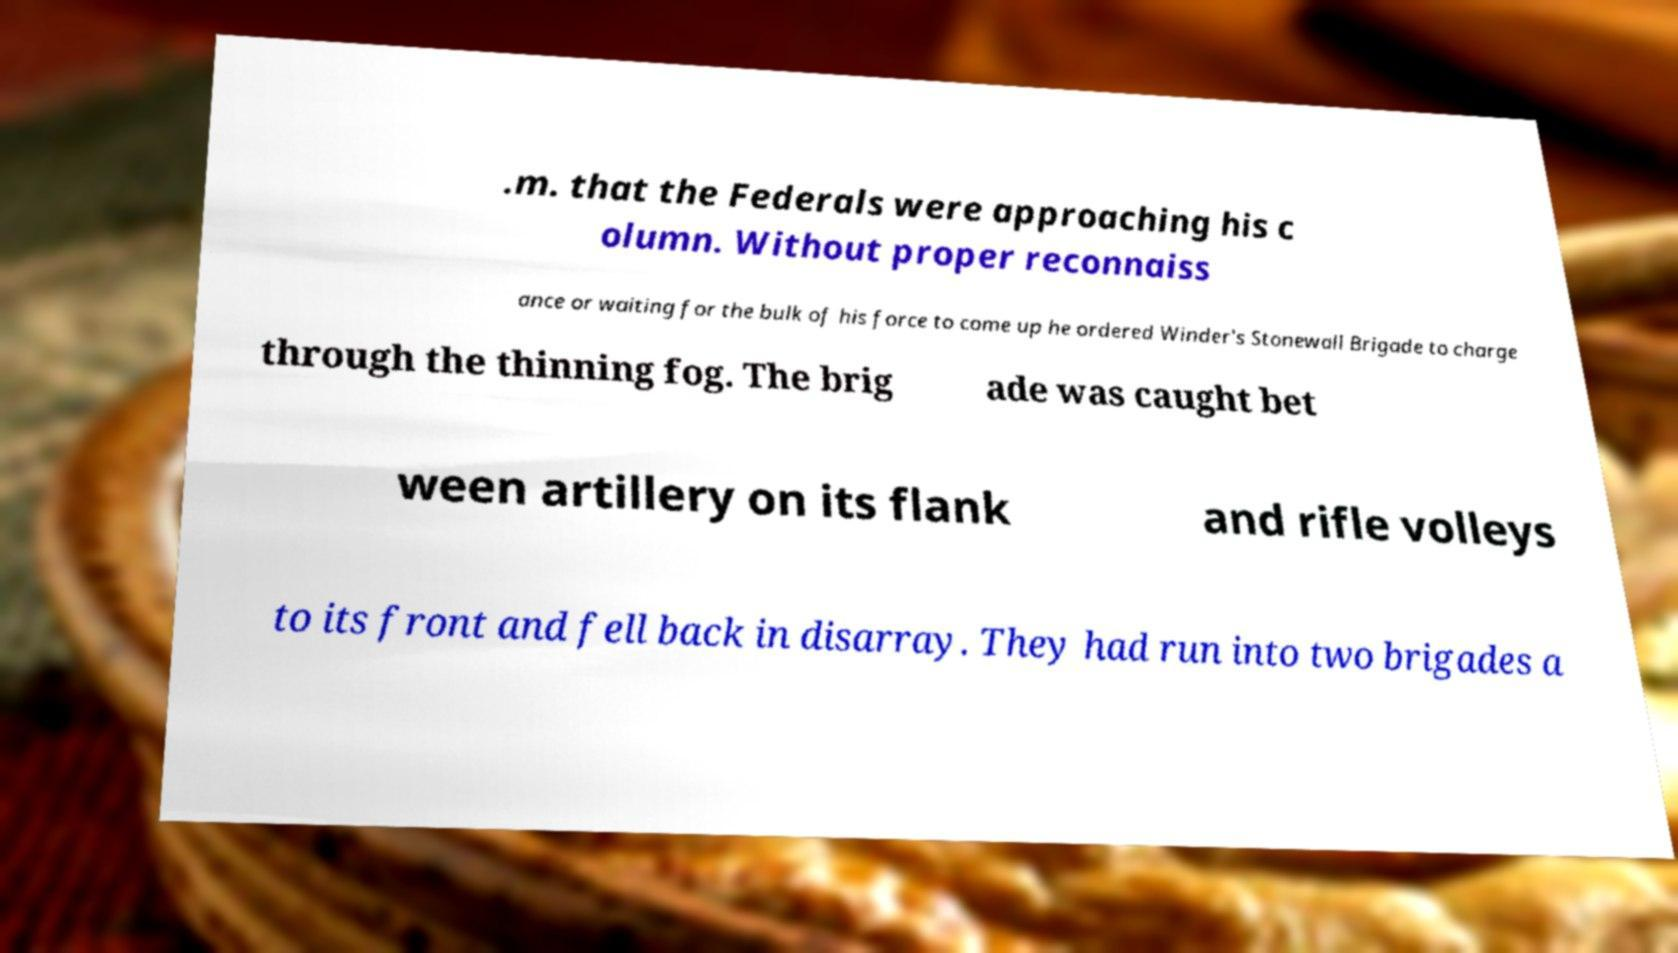What messages or text are displayed in this image? I need them in a readable, typed format. .m. that the Federals were approaching his c olumn. Without proper reconnaiss ance or waiting for the bulk of his force to come up he ordered Winder's Stonewall Brigade to charge through the thinning fog. The brig ade was caught bet ween artillery on its flank and rifle volleys to its front and fell back in disarray. They had run into two brigades a 